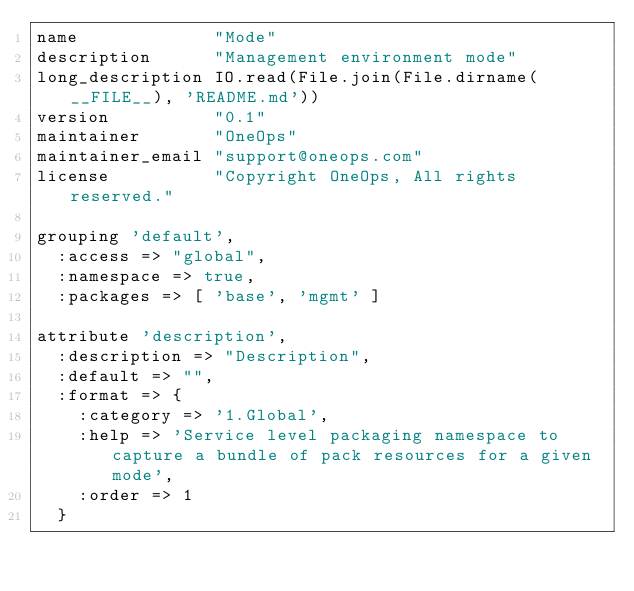<code> <loc_0><loc_0><loc_500><loc_500><_Ruby_>name             "Mode"
description      "Management environment mode"
long_description IO.read(File.join(File.dirname(__FILE__), 'README.md'))
version          "0.1"
maintainer       "OneOps"
maintainer_email "support@oneops.com"
license          "Copyright OneOps, All rights reserved."

grouping 'default',
  :access => "global",
  :namespace => true,
  :packages => [ 'base', 'mgmt' ]
  
attribute 'description',
  :description => "Description",
  :default => "",
  :format => {
    :category => '1.Global',
    :help => 'Service level packaging namespace to capture a bundle of pack resources for a given mode',
    :order => 1
  }

</code> 